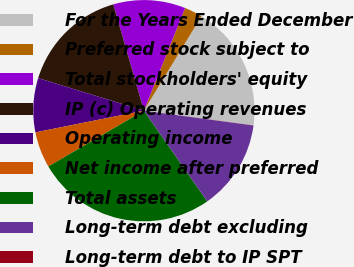Convert chart to OTSL. <chart><loc_0><loc_0><loc_500><loc_500><pie_chart><fcel>For the Years Ended December<fcel>Preferred stock subject to<fcel>Total stockholders' equity<fcel>IP (c) Operating revenues<fcel>Operating income<fcel>Net income after preferred<fcel>Total assets<fcel>Long-term debt excluding<fcel>Long-term debt to IP SPT<nl><fcel>18.41%<fcel>2.64%<fcel>10.53%<fcel>15.78%<fcel>7.9%<fcel>5.27%<fcel>26.29%<fcel>13.15%<fcel>0.02%<nl></chart> 